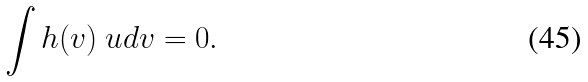Convert formula to latex. <formula><loc_0><loc_0><loc_500><loc_500>\int h ( v ) \ u d { v } = 0 .</formula> 